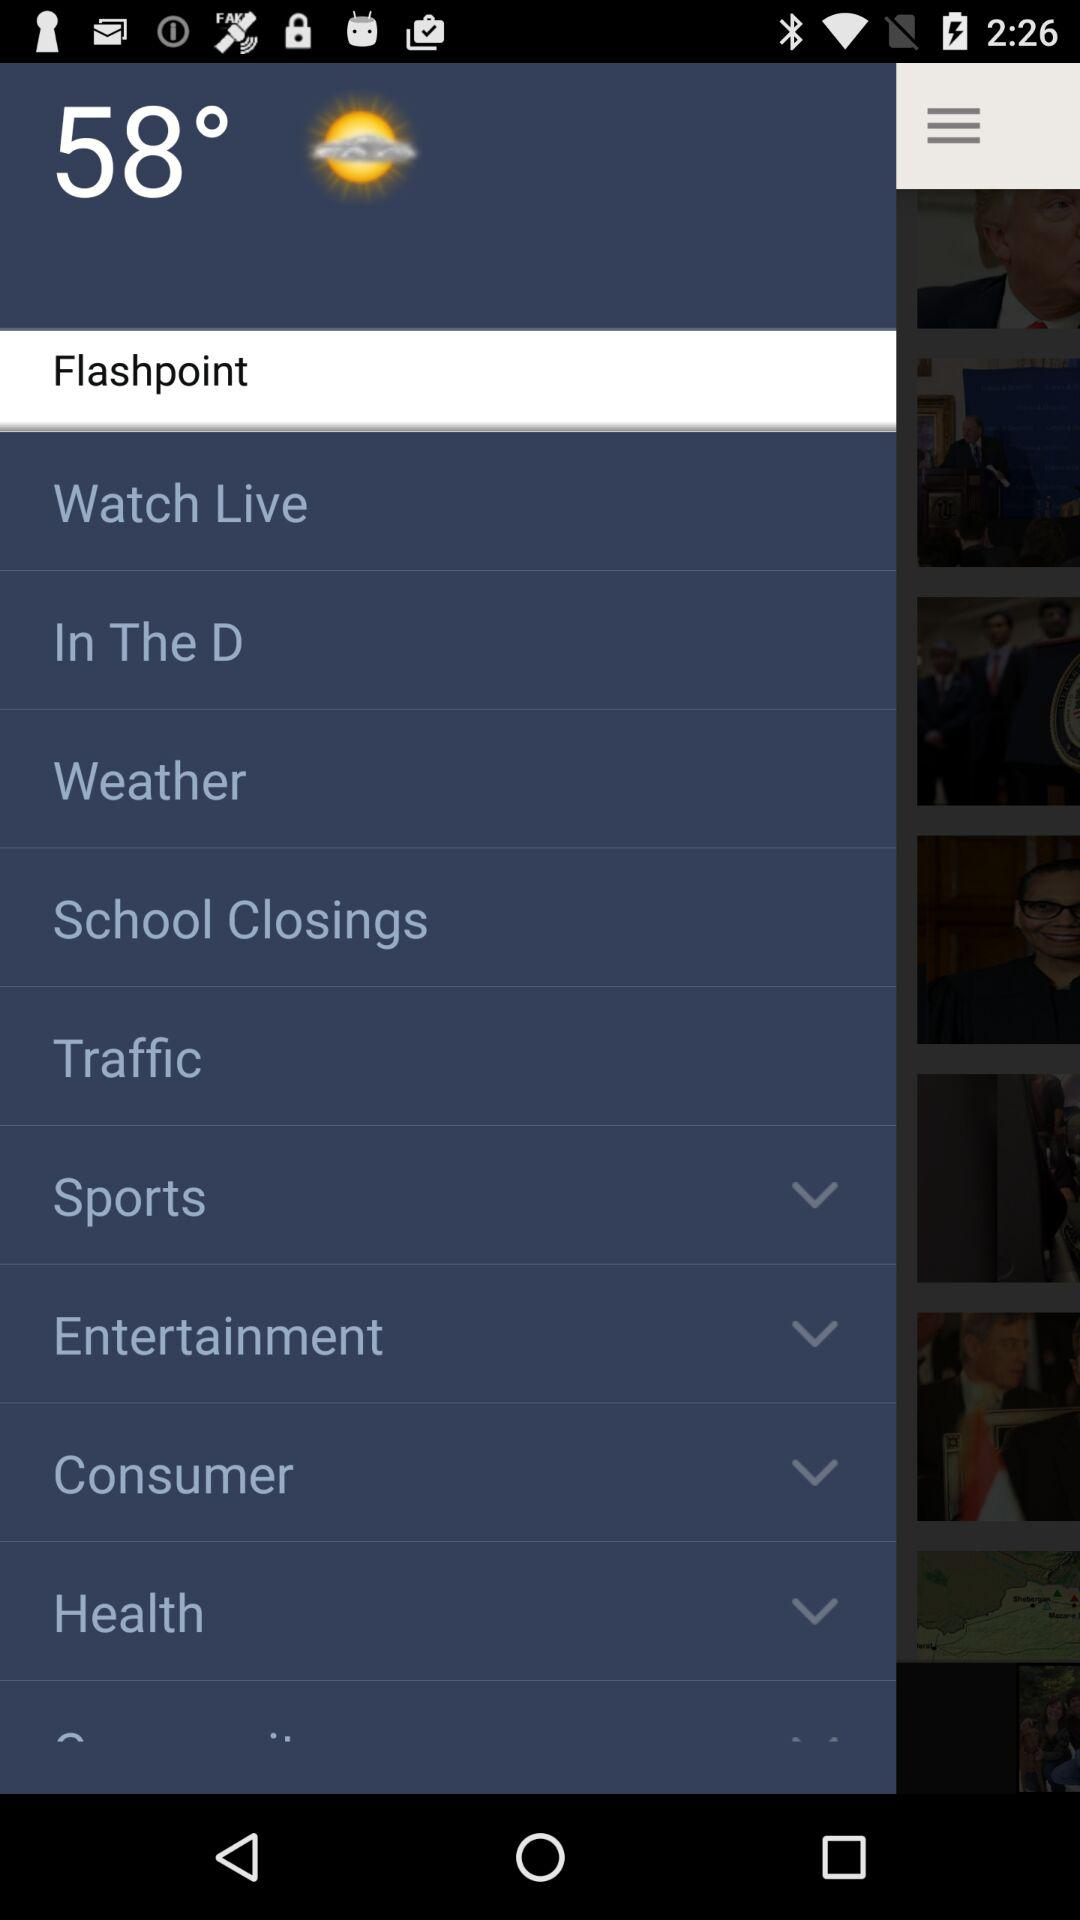What is the temperature? The temperature is 58°. 